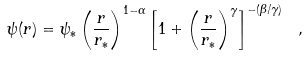Convert formula to latex. <formula><loc_0><loc_0><loc_500><loc_500>\psi ( r ) = \psi _ { * } \left ( \frac { r } { r _ { * } } \right ) ^ { 1 - \alpha } \left [ 1 + \left ( \frac { r } { r _ { * } } \right ) ^ { \gamma } \right ] ^ { - ( \beta / \gamma ) } \ ,</formula> 